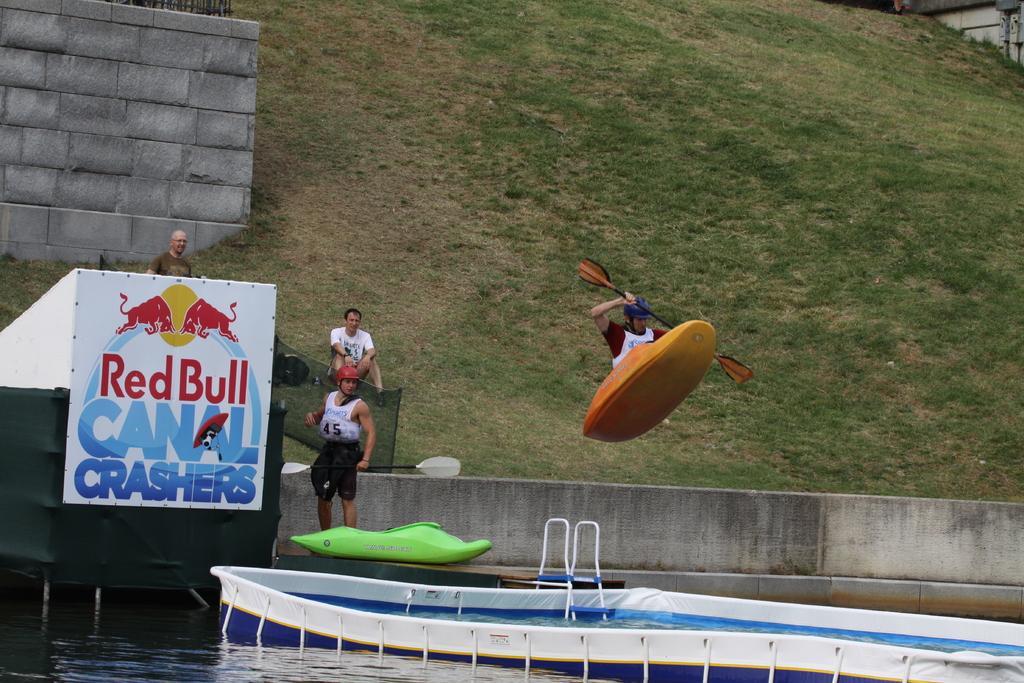In one or two sentences, can you explain what this image depicts? In this image I can see water in the front. In the centre of this image I can see a man and and a boat in the air. I can see he is holding a paddle. On the left side of this image I can see one more boat, few people, a white colour board and on it I can see something is written. In the background I can see an open grass ground. 